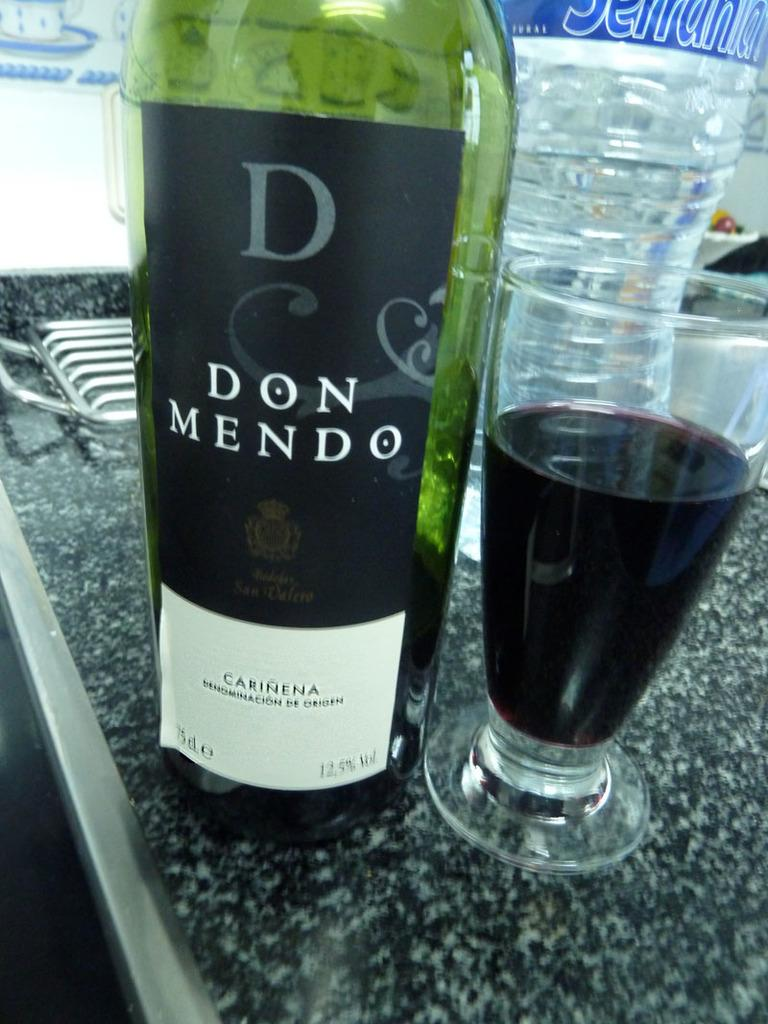Provide a one-sentence caption for the provided image. A bottle of Don Mendo Carinena is sitting on a counter next to a glass. 